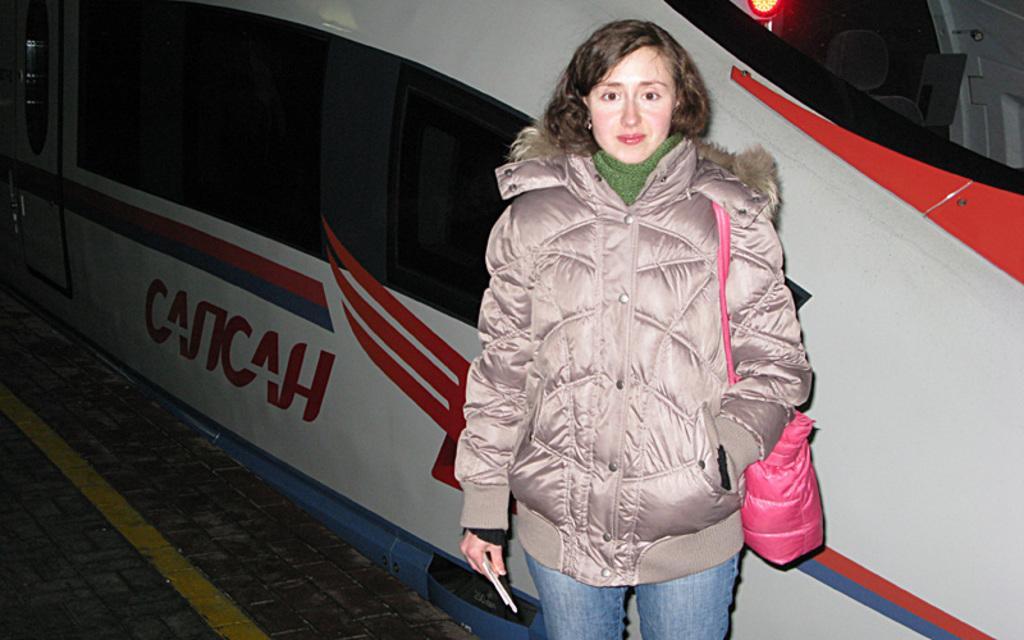How would you summarize this image in a sentence or two? In the picture I can see a woman is wearing a jacket, jeans pant and a bag which is pink in color. In the background I can see an object which has something written on it. 